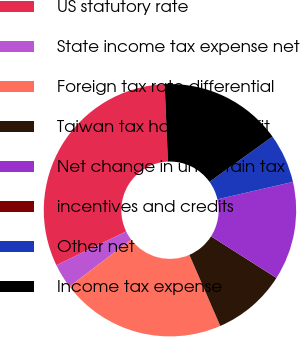<chart> <loc_0><loc_0><loc_500><loc_500><pie_chart><fcel>US statutory rate<fcel>State income tax expense net<fcel>Foreign tax rate differential<fcel>Taiwan tax holiday benefit<fcel>Net change in uncertain tax<fcel>incentives and credits<fcel>Other net<fcel>Income tax expense<nl><fcel>31.51%<fcel>3.16%<fcel>21.19%<fcel>9.46%<fcel>12.61%<fcel>0.01%<fcel>6.31%<fcel>15.76%<nl></chart> 